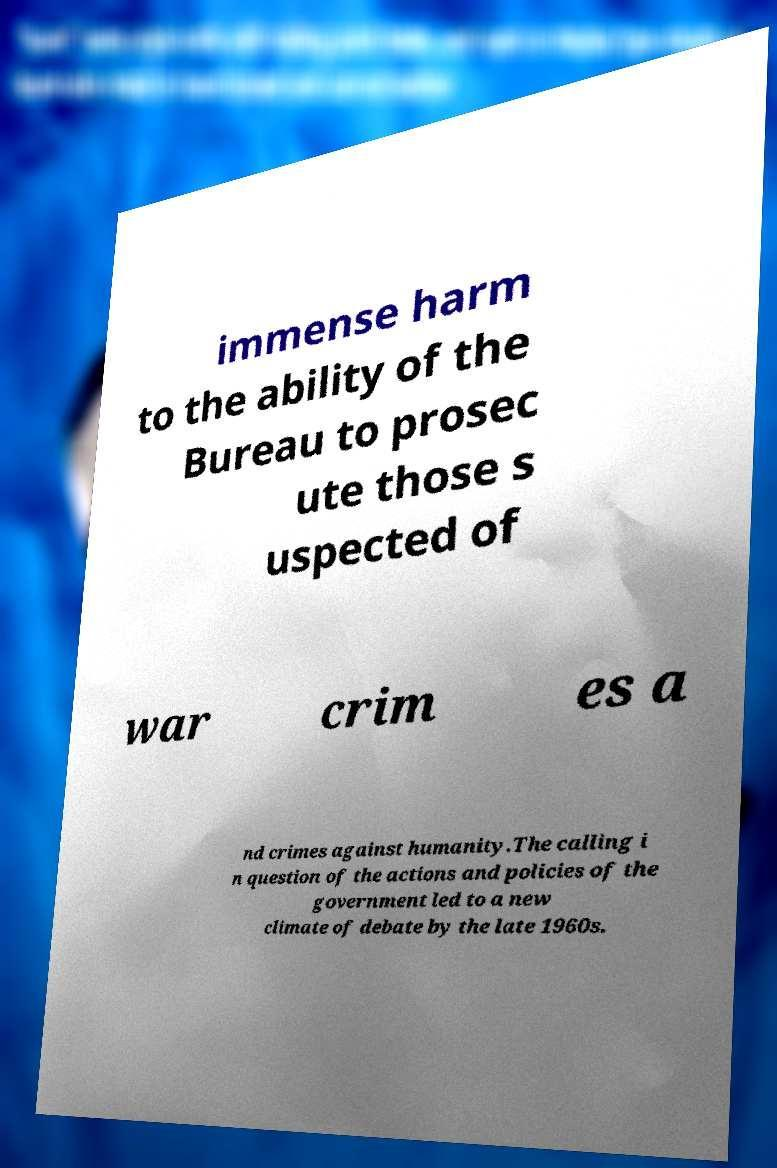Could you assist in decoding the text presented in this image and type it out clearly? immense harm to the ability of the Bureau to prosec ute those s uspected of war crim es a nd crimes against humanity.The calling i n question of the actions and policies of the government led to a new climate of debate by the late 1960s. 